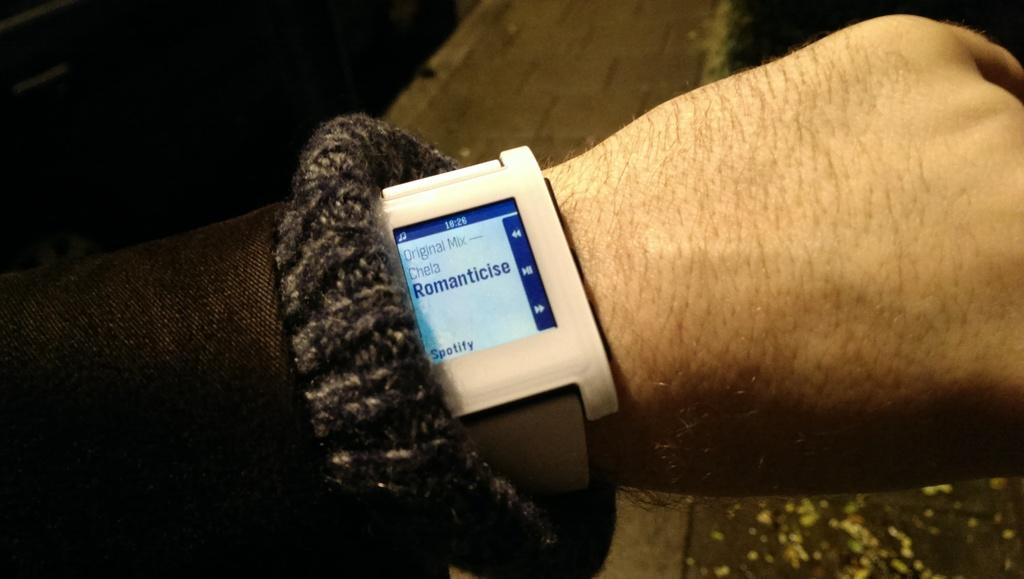What are they listening to?
Ensure brevity in your answer.  Romanticise. What language is the smart watch in?
Offer a terse response. Unanswerable. 